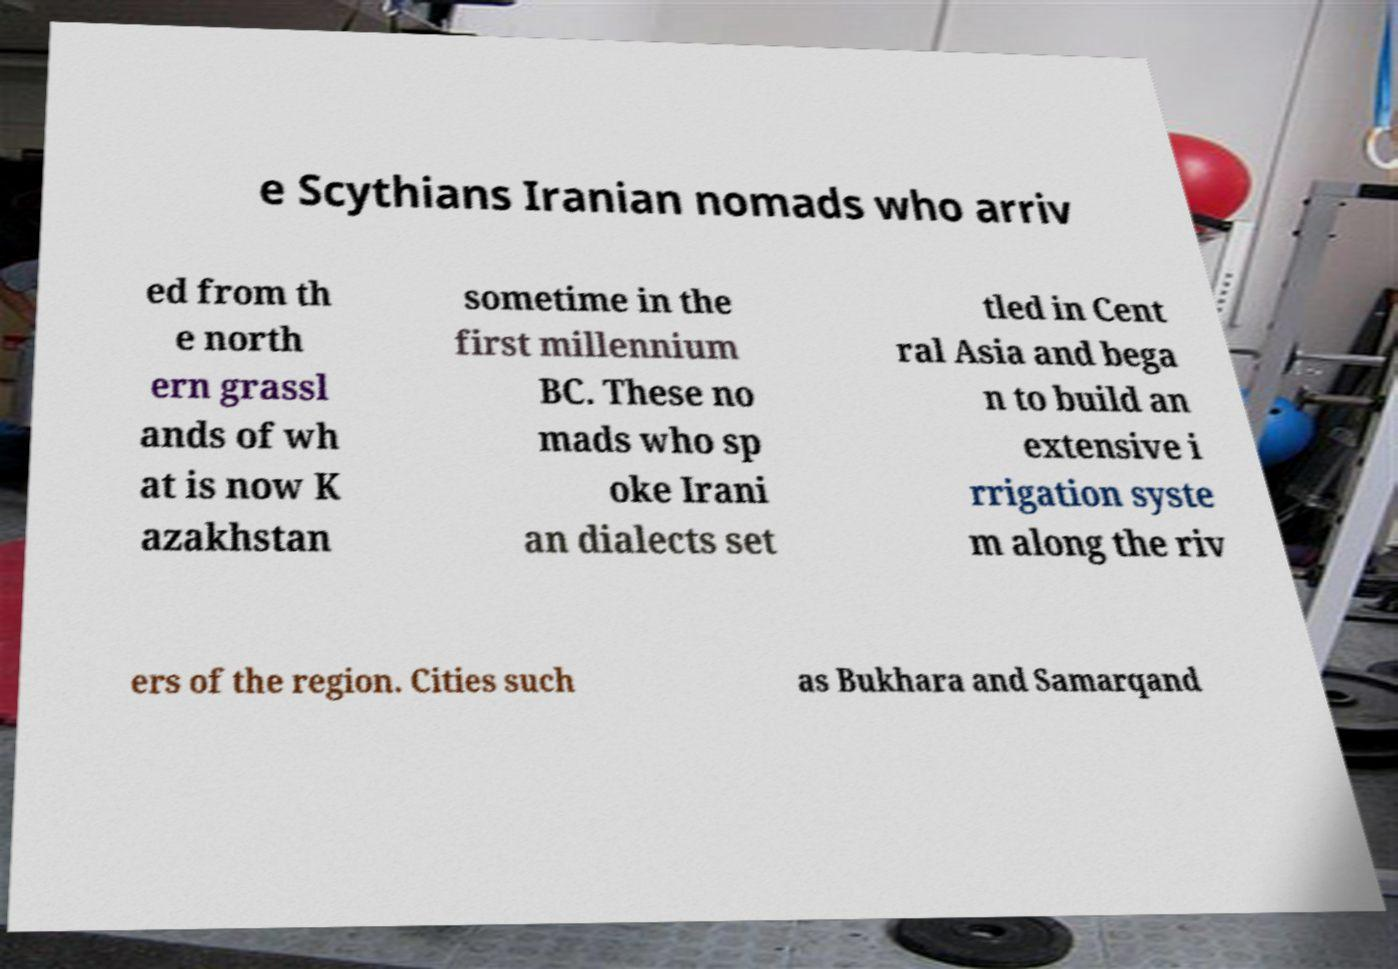Could you extract and type out the text from this image? e Scythians Iranian nomads who arriv ed from th e north ern grassl ands of wh at is now K azakhstan sometime in the first millennium BC. These no mads who sp oke Irani an dialects set tled in Cent ral Asia and bega n to build an extensive i rrigation syste m along the riv ers of the region. Cities such as Bukhara and Samarqand 